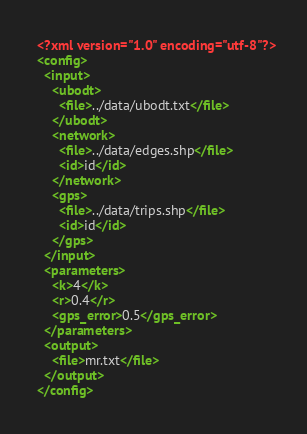<code> <loc_0><loc_0><loc_500><loc_500><_XML_><?xml version="1.0" encoding="utf-8"?>
<config>
  <input>
    <ubodt>
      <file>../data/ubodt.txt</file>
    </ubodt>
    <network>
      <file>../data/edges.shp</file>
      <id>id</id>
    </network>
    <gps>
      <file>../data/trips.shp</file>
      <id>id</id>
    </gps>
  </input>
  <parameters>
    <k>4</k>
    <r>0.4</r>
    <gps_error>0.5</gps_error>
  </parameters>
  <output>
    <file>mr.txt</file>
  </output>
</config>
</code> 